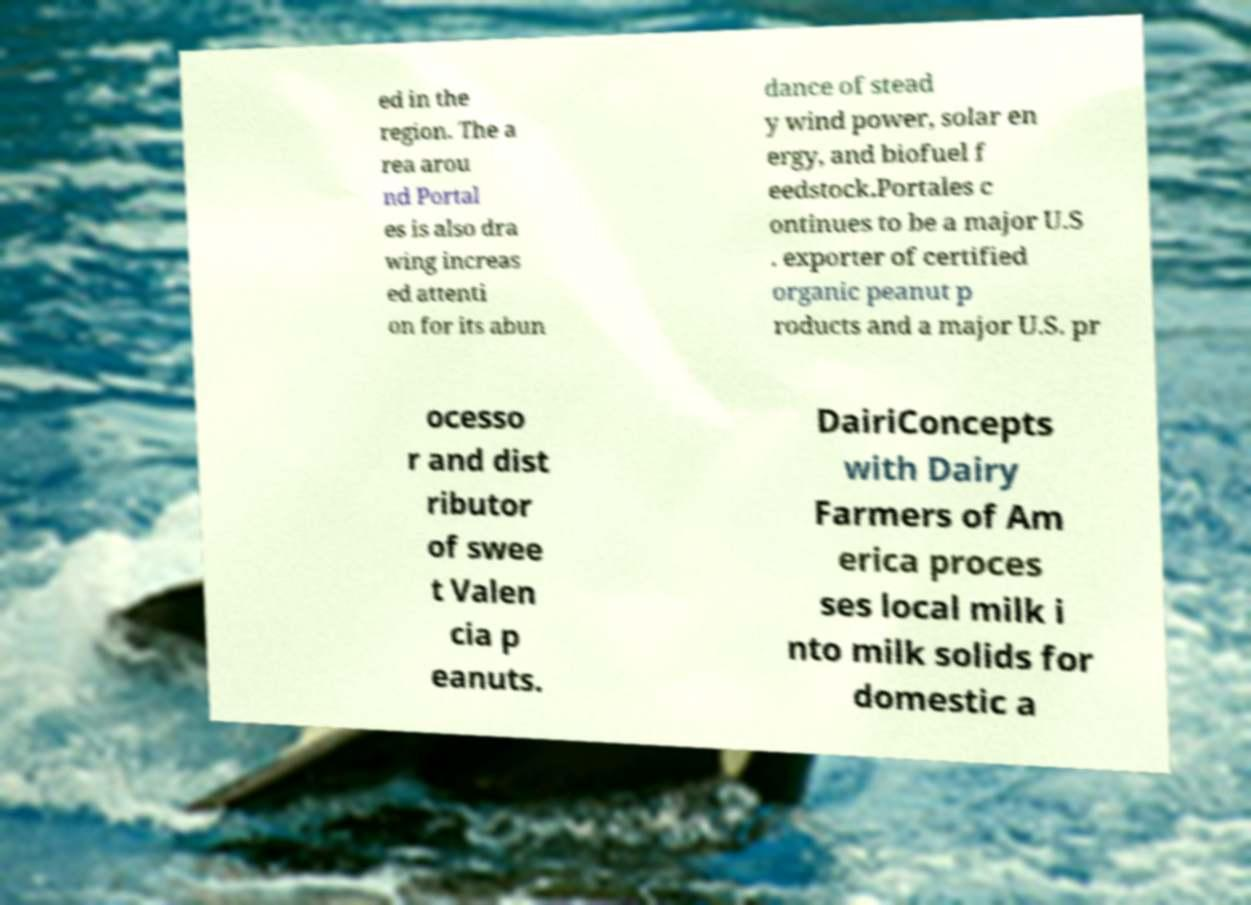I need the written content from this picture converted into text. Can you do that? ed in the region. The a rea arou nd Portal es is also dra wing increas ed attenti on for its abun dance of stead y wind power, solar en ergy, and biofuel f eedstock.Portales c ontinues to be a major U.S . exporter of certified organic peanut p roducts and a major U.S. pr ocesso r and dist ributor of swee t Valen cia p eanuts. DairiConcepts with Dairy Farmers of Am erica proces ses local milk i nto milk solids for domestic a 